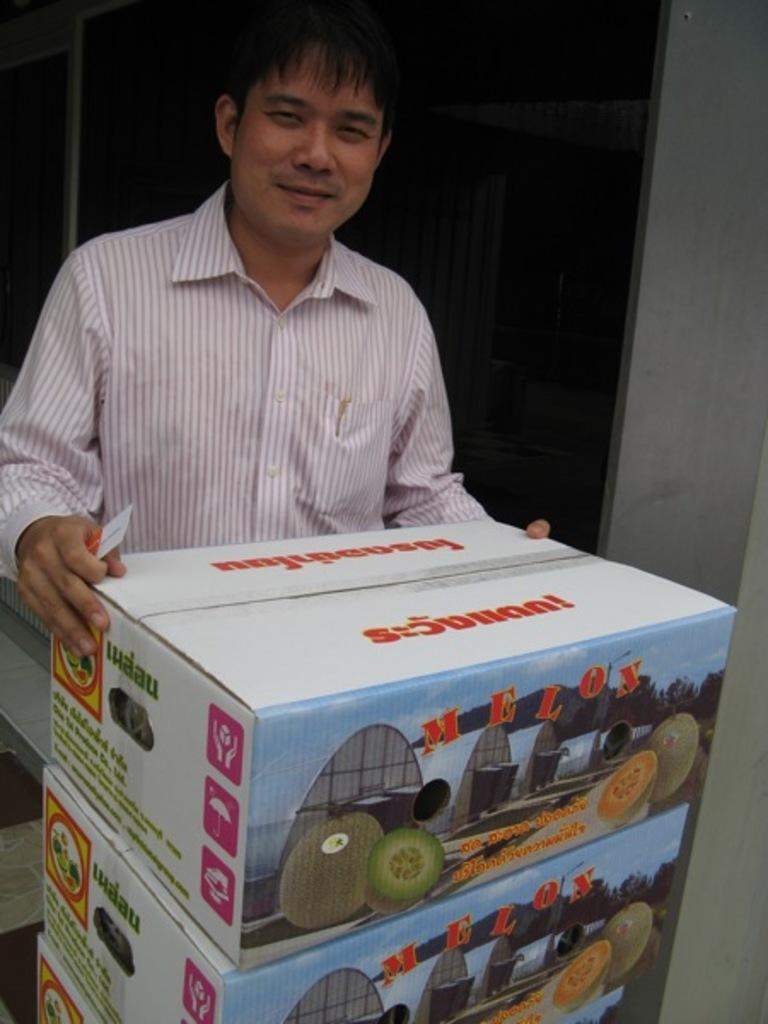Provide a one-sentence caption for the provided image. A man is holding a box with the word Melon on it. 